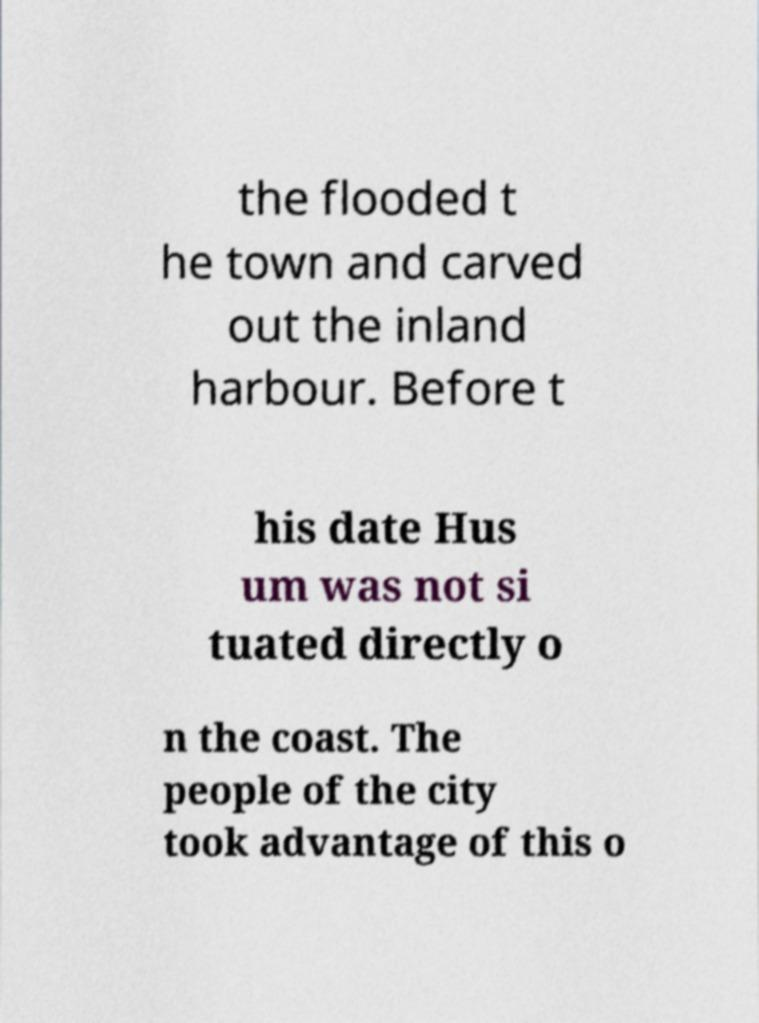Can you read and provide the text displayed in the image?This photo seems to have some interesting text. Can you extract and type it out for me? the flooded t he town and carved out the inland harbour. Before t his date Hus um was not si tuated directly o n the coast. The people of the city took advantage of this o 